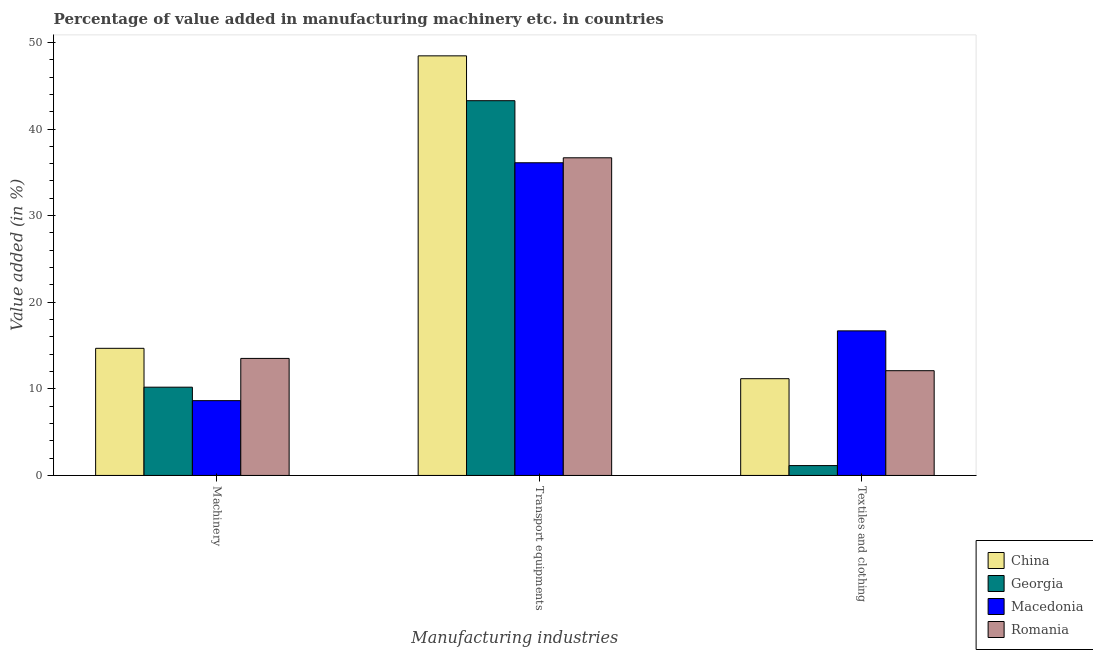How many different coloured bars are there?
Ensure brevity in your answer.  4. How many groups of bars are there?
Your answer should be compact. 3. Are the number of bars per tick equal to the number of legend labels?
Your answer should be compact. Yes. Are the number of bars on each tick of the X-axis equal?
Keep it short and to the point. Yes. What is the label of the 1st group of bars from the left?
Offer a very short reply. Machinery. What is the value added in manufacturing textile and clothing in Georgia?
Offer a very short reply. 1.14. Across all countries, what is the maximum value added in manufacturing textile and clothing?
Offer a very short reply. 16.69. Across all countries, what is the minimum value added in manufacturing transport equipments?
Your answer should be very brief. 36.1. In which country was the value added in manufacturing machinery minimum?
Ensure brevity in your answer.  Macedonia. What is the total value added in manufacturing machinery in the graph?
Your response must be concise. 47.02. What is the difference between the value added in manufacturing machinery in Macedonia and that in Georgia?
Offer a very short reply. -1.55. What is the difference between the value added in manufacturing transport equipments in China and the value added in manufacturing machinery in Georgia?
Make the answer very short. 38.26. What is the average value added in manufacturing transport equipments per country?
Provide a short and direct response. 41.12. What is the difference between the value added in manufacturing textile and clothing and value added in manufacturing transport equipments in Macedonia?
Your response must be concise. -19.41. What is the ratio of the value added in manufacturing transport equipments in Romania to that in Macedonia?
Provide a short and direct response. 1.02. What is the difference between the highest and the second highest value added in manufacturing transport equipments?
Ensure brevity in your answer.  5.18. What is the difference between the highest and the lowest value added in manufacturing machinery?
Keep it short and to the point. 6.04. In how many countries, is the value added in manufacturing transport equipments greater than the average value added in manufacturing transport equipments taken over all countries?
Offer a very short reply. 2. What does the 3rd bar from the right in Textiles and clothing represents?
Ensure brevity in your answer.  Georgia. Is it the case that in every country, the sum of the value added in manufacturing machinery and value added in manufacturing transport equipments is greater than the value added in manufacturing textile and clothing?
Provide a succinct answer. Yes. What is the difference between two consecutive major ticks on the Y-axis?
Offer a very short reply. 10. Are the values on the major ticks of Y-axis written in scientific E-notation?
Provide a succinct answer. No. Does the graph contain any zero values?
Your response must be concise. No. Does the graph contain grids?
Offer a very short reply. No. Where does the legend appear in the graph?
Offer a terse response. Bottom right. What is the title of the graph?
Your answer should be compact. Percentage of value added in manufacturing machinery etc. in countries. Does "Guinea-Bissau" appear as one of the legend labels in the graph?
Your answer should be compact. No. What is the label or title of the X-axis?
Ensure brevity in your answer.  Manufacturing industries. What is the label or title of the Y-axis?
Provide a short and direct response. Value added (in %). What is the Value added (in %) in China in Machinery?
Your answer should be very brief. 14.68. What is the Value added (in %) of Georgia in Machinery?
Your response must be concise. 10.19. What is the Value added (in %) of Macedonia in Machinery?
Ensure brevity in your answer.  8.64. What is the Value added (in %) in Romania in Machinery?
Your answer should be compact. 13.51. What is the Value added (in %) in China in Transport equipments?
Keep it short and to the point. 48.45. What is the Value added (in %) of Georgia in Transport equipments?
Offer a very short reply. 43.27. What is the Value added (in %) in Macedonia in Transport equipments?
Your answer should be compact. 36.1. What is the Value added (in %) in Romania in Transport equipments?
Make the answer very short. 36.68. What is the Value added (in %) of China in Textiles and clothing?
Keep it short and to the point. 11.17. What is the Value added (in %) in Georgia in Textiles and clothing?
Give a very brief answer. 1.14. What is the Value added (in %) of Macedonia in Textiles and clothing?
Your answer should be very brief. 16.69. What is the Value added (in %) in Romania in Textiles and clothing?
Keep it short and to the point. 12.09. Across all Manufacturing industries, what is the maximum Value added (in %) in China?
Give a very brief answer. 48.45. Across all Manufacturing industries, what is the maximum Value added (in %) in Georgia?
Offer a very short reply. 43.27. Across all Manufacturing industries, what is the maximum Value added (in %) of Macedonia?
Ensure brevity in your answer.  36.1. Across all Manufacturing industries, what is the maximum Value added (in %) in Romania?
Give a very brief answer. 36.68. Across all Manufacturing industries, what is the minimum Value added (in %) in China?
Make the answer very short. 11.17. Across all Manufacturing industries, what is the minimum Value added (in %) of Georgia?
Your answer should be compact. 1.14. Across all Manufacturing industries, what is the minimum Value added (in %) in Macedonia?
Ensure brevity in your answer.  8.64. Across all Manufacturing industries, what is the minimum Value added (in %) of Romania?
Make the answer very short. 12.09. What is the total Value added (in %) of China in the graph?
Keep it short and to the point. 74.29. What is the total Value added (in %) in Georgia in the graph?
Provide a short and direct response. 54.6. What is the total Value added (in %) in Macedonia in the graph?
Make the answer very short. 61.43. What is the total Value added (in %) of Romania in the graph?
Your answer should be very brief. 62.28. What is the difference between the Value added (in %) of China in Machinery and that in Transport equipments?
Provide a short and direct response. -33.77. What is the difference between the Value added (in %) in Georgia in Machinery and that in Transport equipments?
Keep it short and to the point. -33.08. What is the difference between the Value added (in %) in Macedonia in Machinery and that in Transport equipments?
Ensure brevity in your answer.  -27.47. What is the difference between the Value added (in %) in Romania in Machinery and that in Transport equipments?
Ensure brevity in your answer.  -23.16. What is the difference between the Value added (in %) of China in Machinery and that in Textiles and clothing?
Your response must be concise. 3.51. What is the difference between the Value added (in %) in Georgia in Machinery and that in Textiles and clothing?
Make the answer very short. 9.05. What is the difference between the Value added (in %) of Macedonia in Machinery and that in Textiles and clothing?
Your response must be concise. -8.06. What is the difference between the Value added (in %) in Romania in Machinery and that in Textiles and clothing?
Provide a succinct answer. 1.42. What is the difference between the Value added (in %) in China in Transport equipments and that in Textiles and clothing?
Offer a terse response. 37.28. What is the difference between the Value added (in %) in Georgia in Transport equipments and that in Textiles and clothing?
Offer a terse response. 42.13. What is the difference between the Value added (in %) of Macedonia in Transport equipments and that in Textiles and clothing?
Offer a very short reply. 19.41. What is the difference between the Value added (in %) of Romania in Transport equipments and that in Textiles and clothing?
Your answer should be very brief. 24.58. What is the difference between the Value added (in %) in China in Machinery and the Value added (in %) in Georgia in Transport equipments?
Offer a very short reply. -28.59. What is the difference between the Value added (in %) of China in Machinery and the Value added (in %) of Macedonia in Transport equipments?
Make the answer very short. -21.42. What is the difference between the Value added (in %) of China in Machinery and the Value added (in %) of Romania in Transport equipments?
Offer a terse response. -22. What is the difference between the Value added (in %) of Georgia in Machinery and the Value added (in %) of Macedonia in Transport equipments?
Your answer should be compact. -25.91. What is the difference between the Value added (in %) of Georgia in Machinery and the Value added (in %) of Romania in Transport equipments?
Give a very brief answer. -26.49. What is the difference between the Value added (in %) in Macedonia in Machinery and the Value added (in %) in Romania in Transport equipments?
Provide a succinct answer. -28.04. What is the difference between the Value added (in %) of China in Machinery and the Value added (in %) of Georgia in Textiles and clothing?
Your response must be concise. 13.54. What is the difference between the Value added (in %) of China in Machinery and the Value added (in %) of Macedonia in Textiles and clothing?
Provide a short and direct response. -2.01. What is the difference between the Value added (in %) in China in Machinery and the Value added (in %) in Romania in Textiles and clothing?
Your response must be concise. 2.58. What is the difference between the Value added (in %) in Georgia in Machinery and the Value added (in %) in Macedonia in Textiles and clothing?
Provide a short and direct response. -6.5. What is the difference between the Value added (in %) of Georgia in Machinery and the Value added (in %) of Romania in Textiles and clothing?
Offer a terse response. -1.9. What is the difference between the Value added (in %) of Macedonia in Machinery and the Value added (in %) of Romania in Textiles and clothing?
Offer a very short reply. -3.46. What is the difference between the Value added (in %) of China in Transport equipments and the Value added (in %) of Georgia in Textiles and clothing?
Your answer should be compact. 47.31. What is the difference between the Value added (in %) in China in Transport equipments and the Value added (in %) in Macedonia in Textiles and clothing?
Make the answer very short. 31.75. What is the difference between the Value added (in %) in China in Transport equipments and the Value added (in %) in Romania in Textiles and clothing?
Make the answer very short. 36.35. What is the difference between the Value added (in %) of Georgia in Transport equipments and the Value added (in %) of Macedonia in Textiles and clothing?
Give a very brief answer. 26.58. What is the difference between the Value added (in %) in Georgia in Transport equipments and the Value added (in %) in Romania in Textiles and clothing?
Provide a succinct answer. 31.18. What is the difference between the Value added (in %) of Macedonia in Transport equipments and the Value added (in %) of Romania in Textiles and clothing?
Provide a succinct answer. 24.01. What is the average Value added (in %) in China per Manufacturing industries?
Keep it short and to the point. 24.76. What is the average Value added (in %) of Georgia per Manufacturing industries?
Your response must be concise. 18.2. What is the average Value added (in %) in Macedonia per Manufacturing industries?
Your response must be concise. 20.48. What is the average Value added (in %) of Romania per Manufacturing industries?
Your answer should be very brief. 20.76. What is the difference between the Value added (in %) in China and Value added (in %) in Georgia in Machinery?
Provide a succinct answer. 4.49. What is the difference between the Value added (in %) of China and Value added (in %) of Macedonia in Machinery?
Keep it short and to the point. 6.04. What is the difference between the Value added (in %) in China and Value added (in %) in Romania in Machinery?
Provide a short and direct response. 1.17. What is the difference between the Value added (in %) in Georgia and Value added (in %) in Macedonia in Machinery?
Make the answer very short. 1.55. What is the difference between the Value added (in %) of Georgia and Value added (in %) of Romania in Machinery?
Make the answer very short. -3.32. What is the difference between the Value added (in %) of Macedonia and Value added (in %) of Romania in Machinery?
Give a very brief answer. -4.88. What is the difference between the Value added (in %) in China and Value added (in %) in Georgia in Transport equipments?
Your answer should be compact. 5.18. What is the difference between the Value added (in %) in China and Value added (in %) in Macedonia in Transport equipments?
Your answer should be compact. 12.34. What is the difference between the Value added (in %) of China and Value added (in %) of Romania in Transport equipments?
Keep it short and to the point. 11.77. What is the difference between the Value added (in %) in Georgia and Value added (in %) in Macedonia in Transport equipments?
Your response must be concise. 7.17. What is the difference between the Value added (in %) in Georgia and Value added (in %) in Romania in Transport equipments?
Provide a succinct answer. 6.59. What is the difference between the Value added (in %) in Macedonia and Value added (in %) in Romania in Transport equipments?
Provide a short and direct response. -0.57. What is the difference between the Value added (in %) in China and Value added (in %) in Georgia in Textiles and clothing?
Offer a very short reply. 10.03. What is the difference between the Value added (in %) in China and Value added (in %) in Macedonia in Textiles and clothing?
Provide a succinct answer. -5.52. What is the difference between the Value added (in %) of China and Value added (in %) of Romania in Textiles and clothing?
Ensure brevity in your answer.  -0.92. What is the difference between the Value added (in %) of Georgia and Value added (in %) of Macedonia in Textiles and clothing?
Give a very brief answer. -15.55. What is the difference between the Value added (in %) in Georgia and Value added (in %) in Romania in Textiles and clothing?
Offer a very short reply. -10.96. What is the difference between the Value added (in %) in Macedonia and Value added (in %) in Romania in Textiles and clothing?
Provide a succinct answer. 4.6. What is the ratio of the Value added (in %) of China in Machinery to that in Transport equipments?
Your answer should be compact. 0.3. What is the ratio of the Value added (in %) in Georgia in Machinery to that in Transport equipments?
Your answer should be compact. 0.24. What is the ratio of the Value added (in %) of Macedonia in Machinery to that in Transport equipments?
Give a very brief answer. 0.24. What is the ratio of the Value added (in %) in Romania in Machinery to that in Transport equipments?
Keep it short and to the point. 0.37. What is the ratio of the Value added (in %) in China in Machinery to that in Textiles and clothing?
Give a very brief answer. 1.31. What is the ratio of the Value added (in %) in Georgia in Machinery to that in Textiles and clothing?
Make the answer very short. 8.96. What is the ratio of the Value added (in %) in Macedonia in Machinery to that in Textiles and clothing?
Your response must be concise. 0.52. What is the ratio of the Value added (in %) of Romania in Machinery to that in Textiles and clothing?
Ensure brevity in your answer.  1.12. What is the ratio of the Value added (in %) in China in Transport equipments to that in Textiles and clothing?
Provide a succinct answer. 4.34. What is the ratio of the Value added (in %) in Georgia in Transport equipments to that in Textiles and clothing?
Provide a succinct answer. 38.03. What is the ratio of the Value added (in %) in Macedonia in Transport equipments to that in Textiles and clothing?
Your answer should be compact. 2.16. What is the ratio of the Value added (in %) in Romania in Transport equipments to that in Textiles and clothing?
Make the answer very short. 3.03. What is the difference between the highest and the second highest Value added (in %) of China?
Give a very brief answer. 33.77. What is the difference between the highest and the second highest Value added (in %) of Georgia?
Give a very brief answer. 33.08. What is the difference between the highest and the second highest Value added (in %) of Macedonia?
Provide a succinct answer. 19.41. What is the difference between the highest and the second highest Value added (in %) of Romania?
Ensure brevity in your answer.  23.16. What is the difference between the highest and the lowest Value added (in %) in China?
Provide a succinct answer. 37.28. What is the difference between the highest and the lowest Value added (in %) in Georgia?
Give a very brief answer. 42.13. What is the difference between the highest and the lowest Value added (in %) in Macedonia?
Offer a terse response. 27.47. What is the difference between the highest and the lowest Value added (in %) in Romania?
Give a very brief answer. 24.58. 